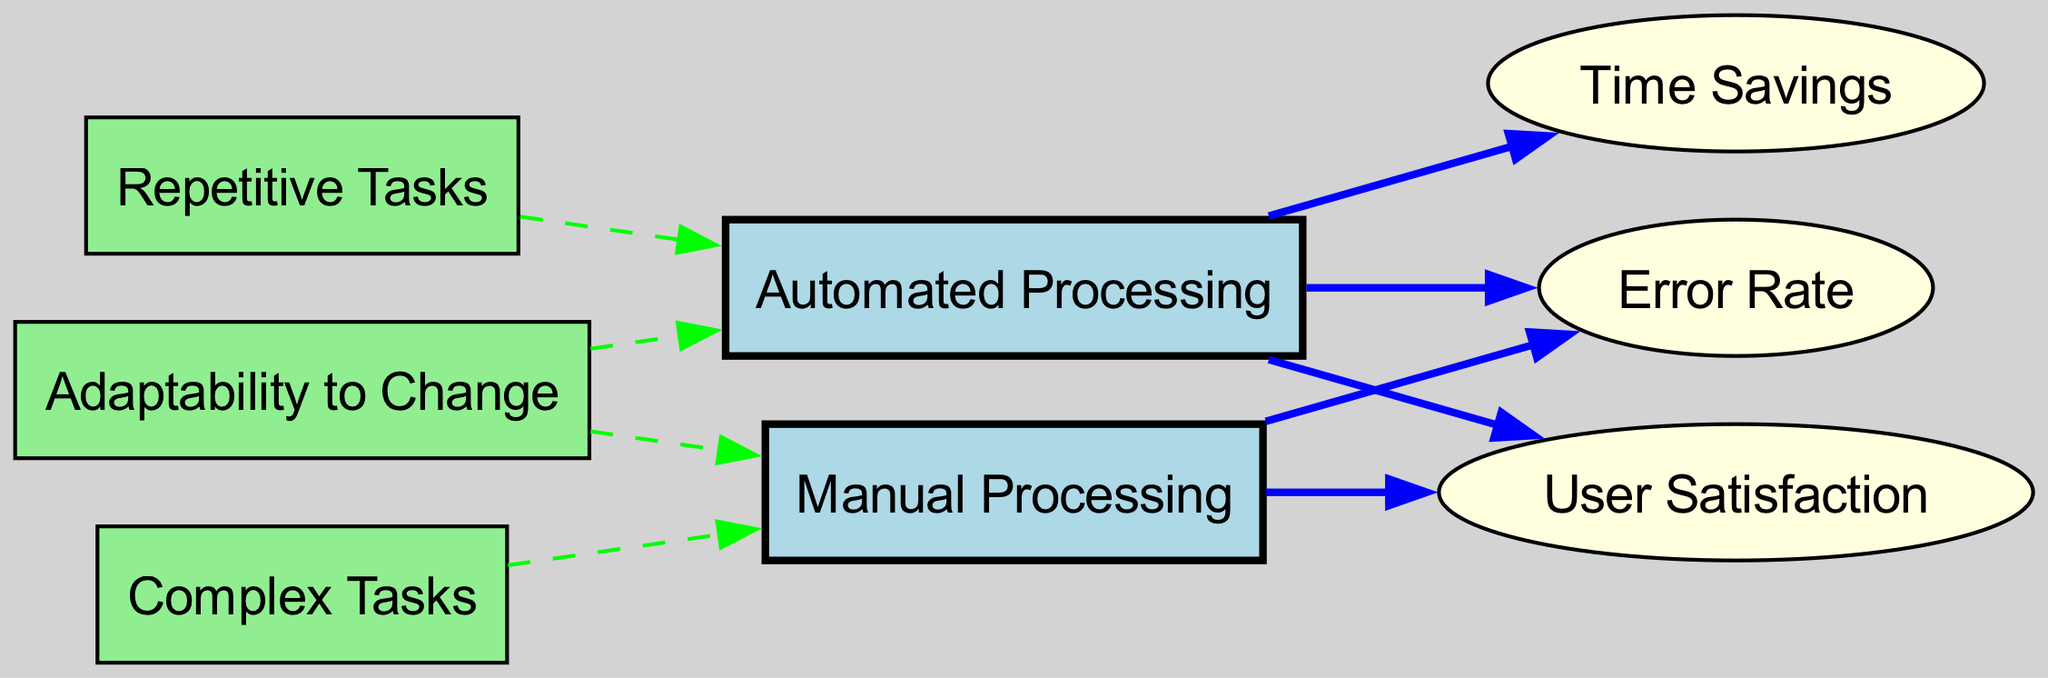What are the two main types of processing compared in the diagram? The diagram includes two main nodes labeled "Automated Processing" and "Manual Processing." These nodes represent the two types of task completion systems that are being compared.
Answer: Automated Processing, Manual Processing How many nodes are present in the diagram? By counting the total number of distinct nodes listed in the data, we can see there are eight nodes, which include both processing types and related concepts.
Answer: Eight What is the relationship between Automated Processing and Time Savings? In the diagram, there is a directed edge from "Automated Processing" to "Time Savings," indicating that automated processing is associated with the concept of time savings.
Answer: Direct Which type of processing is associated with Complex Tasks? The directed edge in the diagram shows that "Complex Tasks" leads to "Manual Processing," indicating that complex tasks are associated with manual processing.
Answer: Manual Processing What is the error rate effect due to manual processing based on the diagram? According to the directed edges in the diagram, there is an edge from "Manual Processing" to "Error Rate," signifying that there is an effect on the error rate resulting from manual processing.
Answer: Effect If adaptability to change is high, which processing type is it more likely to lead to? The "Adaptability to Change" node points to both "Automated Processing" and "Manual Processing." In terms of potential outcomes in relation to adaptability, it could lead to either type of processing based on the scenario.
Answer: Both Which processing type generally has higher user satisfaction? The diagram indicates with direct edges that both automated processing and manual processing contribute to user satisfaction, but automated processing is shown to have a more positive relationship with it.
Answer: Automated Processing Which task type is more likely to be automated, repetitive or complex tasks? The directed edge from "Repetitive Tasks" to "Automated Processing" illustrates that repetitive tasks are more likely to be automated compared to complex tasks, which lead to manual processing.
Answer: Repetitive Tasks How does adaptability to change influence error rates in processing? Adaptability to Change points to both processing types. Automated processing generally has a positive effect (lower error rate), whereas manual processing may show mixed effects, but ultimately, adaptability improves performance in both contexts.
Answer: Positive Influence 